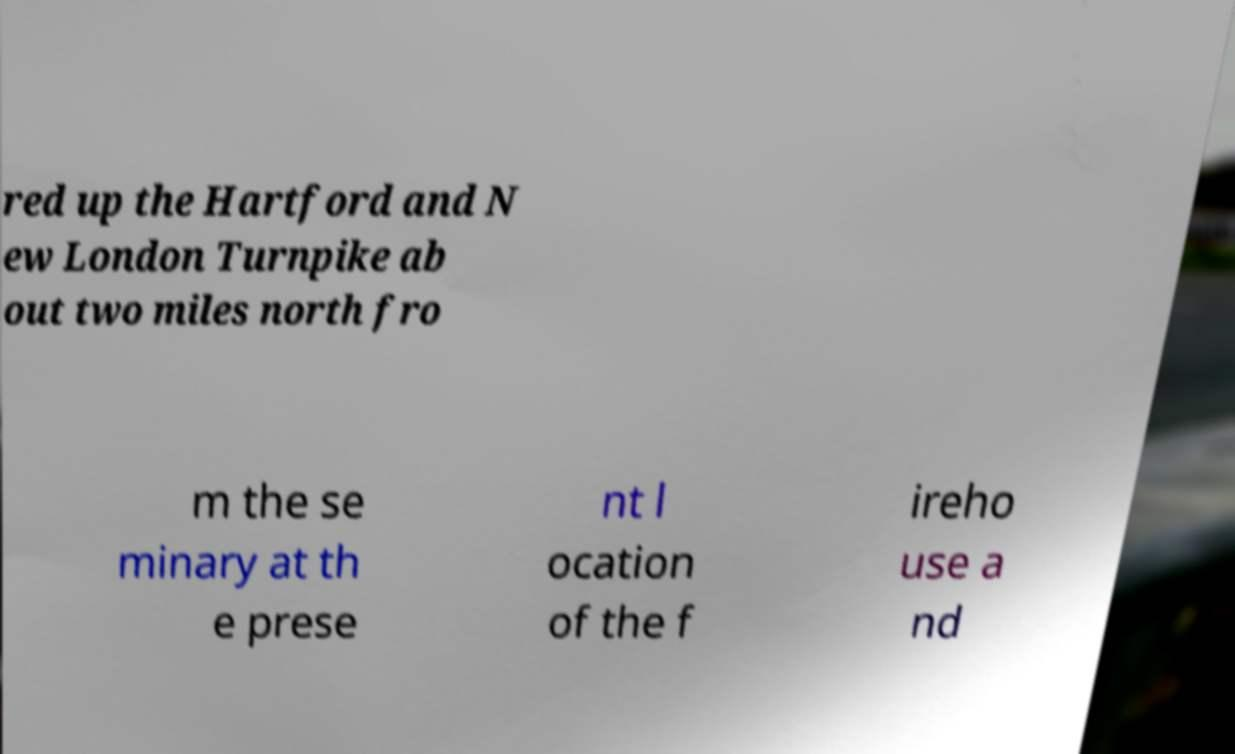I need the written content from this picture converted into text. Can you do that? red up the Hartford and N ew London Turnpike ab out two miles north fro m the se minary at th e prese nt l ocation of the f ireho use a nd 